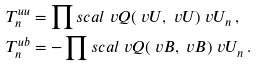<formula> <loc_0><loc_0><loc_500><loc_500>T ^ { u u } _ { n } & = \prod s c a l { \ v Q ( \ v U , \ v U ) } { \ v U _ { n } } \, , \\ T ^ { u b } _ { n } & = - \prod s c a l { \ v Q ( \ v B , \ v B ) } { \ v U _ { n } } \, .</formula> 